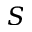Convert formula to latex. <formula><loc_0><loc_0><loc_500><loc_500>S</formula> 